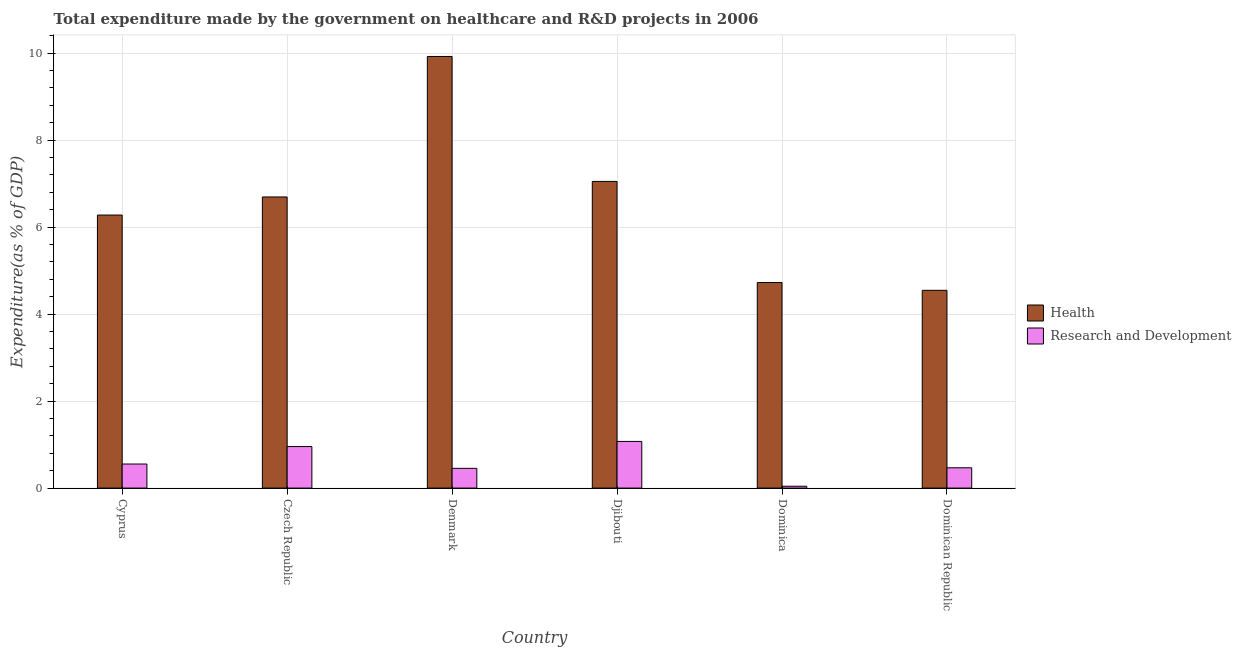Are the number of bars per tick equal to the number of legend labels?
Ensure brevity in your answer.  Yes. Are the number of bars on each tick of the X-axis equal?
Keep it short and to the point. Yes. How many bars are there on the 3rd tick from the left?
Provide a short and direct response. 2. What is the expenditure in r&d in Denmark?
Make the answer very short. 0.45. Across all countries, what is the maximum expenditure in r&d?
Your answer should be very brief. 1.07. Across all countries, what is the minimum expenditure in r&d?
Provide a succinct answer. 0.04. In which country was the expenditure in r&d maximum?
Provide a short and direct response. Djibouti. In which country was the expenditure in healthcare minimum?
Provide a short and direct response. Dominican Republic. What is the total expenditure in healthcare in the graph?
Your answer should be very brief. 39.22. What is the difference between the expenditure in r&d in Cyprus and that in Czech Republic?
Provide a succinct answer. -0.4. What is the difference between the expenditure in r&d in Djibouti and the expenditure in healthcare in Cyprus?
Keep it short and to the point. -5.21. What is the average expenditure in r&d per country?
Your answer should be very brief. 0.59. What is the difference between the expenditure in healthcare and expenditure in r&d in Dominica?
Offer a terse response. 4.68. What is the ratio of the expenditure in healthcare in Cyprus to that in Denmark?
Your answer should be compact. 0.63. Is the expenditure in healthcare in Czech Republic less than that in Dominican Republic?
Give a very brief answer. No. Is the difference between the expenditure in r&d in Cyprus and Czech Republic greater than the difference between the expenditure in healthcare in Cyprus and Czech Republic?
Offer a terse response. Yes. What is the difference between the highest and the second highest expenditure in healthcare?
Your response must be concise. 2.87. What is the difference between the highest and the lowest expenditure in r&d?
Ensure brevity in your answer.  1.03. Is the sum of the expenditure in r&d in Dominica and Dominican Republic greater than the maximum expenditure in healthcare across all countries?
Give a very brief answer. No. What does the 1st bar from the left in Dominican Republic represents?
Ensure brevity in your answer.  Health. What does the 1st bar from the right in Cyprus represents?
Keep it short and to the point. Research and Development. Are all the bars in the graph horizontal?
Offer a terse response. No. How many countries are there in the graph?
Your answer should be compact. 6. What is the difference between two consecutive major ticks on the Y-axis?
Make the answer very short. 2. Are the values on the major ticks of Y-axis written in scientific E-notation?
Ensure brevity in your answer.  No. Where does the legend appear in the graph?
Your answer should be very brief. Center right. How many legend labels are there?
Offer a very short reply. 2. What is the title of the graph?
Your response must be concise. Total expenditure made by the government on healthcare and R&D projects in 2006. What is the label or title of the Y-axis?
Make the answer very short. Expenditure(as % of GDP). What is the Expenditure(as % of GDP) in Health in Cyprus?
Your answer should be compact. 6.28. What is the Expenditure(as % of GDP) in Research and Development in Cyprus?
Offer a terse response. 0.55. What is the Expenditure(as % of GDP) in Health in Czech Republic?
Your answer should be compact. 6.69. What is the Expenditure(as % of GDP) of Research and Development in Czech Republic?
Offer a terse response. 0.95. What is the Expenditure(as % of GDP) of Health in Denmark?
Make the answer very short. 9.92. What is the Expenditure(as % of GDP) in Research and Development in Denmark?
Your answer should be very brief. 0.45. What is the Expenditure(as % of GDP) of Health in Djibouti?
Your answer should be very brief. 7.05. What is the Expenditure(as % of GDP) of Research and Development in Djibouti?
Your response must be concise. 1.07. What is the Expenditure(as % of GDP) of Health in Dominica?
Your answer should be compact. 4.73. What is the Expenditure(as % of GDP) in Research and Development in Dominica?
Keep it short and to the point. 0.04. What is the Expenditure(as % of GDP) of Health in Dominican Republic?
Your response must be concise. 4.55. What is the Expenditure(as % of GDP) in Research and Development in Dominican Republic?
Ensure brevity in your answer.  0.47. Across all countries, what is the maximum Expenditure(as % of GDP) of Health?
Provide a short and direct response. 9.92. Across all countries, what is the maximum Expenditure(as % of GDP) of Research and Development?
Give a very brief answer. 1.07. Across all countries, what is the minimum Expenditure(as % of GDP) in Health?
Offer a terse response. 4.55. Across all countries, what is the minimum Expenditure(as % of GDP) of Research and Development?
Your answer should be very brief. 0.04. What is the total Expenditure(as % of GDP) in Health in the graph?
Offer a very short reply. 39.22. What is the total Expenditure(as % of GDP) of Research and Development in the graph?
Give a very brief answer. 3.54. What is the difference between the Expenditure(as % of GDP) in Health in Cyprus and that in Czech Republic?
Make the answer very short. -0.42. What is the difference between the Expenditure(as % of GDP) of Research and Development in Cyprus and that in Czech Republic?
Ensure brevity in your answer.  -0.4. What is the difference between the Expenditure(as % of GDP) in Health in Cyprus and that in Denmark?
Keep it short and to the point. -3.65. What is the difference between the Expenditure(as % of GDP) of Research and Development in Cyprus and that in Denmark?
Provide a succinct answer. 0.1. What is the difference between the Expenditure(as % of GDP) of Health in Cyprus and that in Djibouti?
Your answer should be compact. -0.77. What is the difference between the Expenditure(as % of GDP) in Research and Development in Cyprus and that in Djibouti?
Your answer should be compact. -0.52. What is the difference between the Expenditure(as % of GDP) in Health in Cyprus and that in Dominica?
Provide a succinct answer. 1.55. What is the difference between the Expenditure(as % of GDP) of Research and Development in Cyprus and that in Dominica?
Your answer should be compact. 0.51. What is the difference between the Expenditure(as % of GDP) of Health in Cyprus and that in Dominican Republic?
Offer a terse response. 1.73. What is the difference between the Expenditure(as % of GDP) in Research and Development in Cyprus and that in Dominican Republic?
Keep it short and to the point. 0.09. What is the difference between the Expenditure(as % of GDP) in Health in Czech Republic and that in Denmark?
Make the answer very short. -3.23. What is the difference between the Expenditure(as % of GDP) of Research and Development in Czech Republic and that in Denmark?
Offer a very short reply. 0.5. What is the difference between the Expenditure(as % of GDP) in Health in Czech Republic and that in Djibouti?
Provide a short and direct response. -0.36. What is the difference between the Expenditure(as % of GDP) in Research and Development in Czech Republic and that in Djibouti?
Your answer should be very brief. -0.12. What is the difference between the Expenditure(as % of GDP) in Health in Czech Republic and that in Dominica?
Keep it short and to the point. 1.97. What is the difference between the Expenditure(as % of GDP) of Research and Development in Czech Republic and that in Dominica?
Provide a short and direct response. 0.91. What is the difference between the Expenditure(as % of GDP) in Health in Czech Republic and that in Dominican Republic?
Your response must be concise. 2.15. What is the difference between the Expenditure(as % of GDP) of Research and Development in Czech Republic and that in Dominican Republic?
Your answer should be compact. 0.49. What is the difference between the Expenditure(as % of GDP) of Health in Denmark and that in Djibouti?
Offer a very short reply. 2.87. What is the difference between the Expenditure(as % of GDP) of Research and Development in Denmark and that in Djibouti?
Offer a terse response. -0.62. What is the difference between the Expenditure(as % of GDP) of Health in Denmark and that in Dominica?
Ensure brevity in your answer.  5.2. What is the difference between the Expenditure(as % of GDP) of Research and Development in Denmark and that in Dominica?
Offer a very short reply. 0.41. What is the difference between the Expenditure(as % of GDP) in Health in Denmark and that in Dominican Republic?
Make the answer very short. 5.38. What is the difference between the Expenditure(as % of GDP) in Research and Development in Denmark and that in Dominican Republic?
Give a very brief answer. -0.01. What is the difference between the Expenditure(as % of GDP) of Health in Djibouti and that in Dominica?
Provide a succinct answer. 2.32. What is the difference between the Expenditure(as % of GDP) of Research and Development in Djibouti and that in Dominica?
Provide a succinct answer. 1.03. What is the difference between the Expenditure(as % of GDP) in Health in Djibouti and that in Dominican Republic?
Keep it short and to the point. 2.5. What is the difference between the Expenditure(as % of GDP) of Research and Development in Djibouti and that in Dominican Republic?
Provide a succinct answer. 0.61. What is the difference between the Expenditure(as % of GDP) of Health in Dominica and that in Dominican Republic?
Provide a short and direct response. 0.18. What is the difference between the Expenditure(as % of GDP) in Research and Development in Dominica and that in Dominican Republic?
Provide a short and direct response. -0.42. What is the difference between the Expenditure(as % of GDP) in Health in Cyprus and the Expenditure(as % of GDP) in Research and Development in Czech Republic?
Offer a terse response. 5.32. What is the difference between the Expenditure(as % of GDP) of Health in Cyprus and the Expenditure(as % of GDP) of Research and Development in Denmark?
Your answer should be very brief. 5.82. What is the difference between the Expenditure(as % of GDP) in Health in Cyprus and the Expenditure(as % of GDP) in Research and Development in Djibouti?
Ensure brevity in your answer.  5.21. What is the difference between the Expenditure(as % of GDP) of Health in Cyprus and the Expenditure(as % of GDP) of Research and Development in Dominica?
Offer a terse response. 6.24. What is the difference between the Expenditure(as % of GDP) of Health in Cyprus and the Expenditure(as % of GDP) of Research and Development in Dominican Republic?
Ensure brevity in your answer.  5.81. What is the difference between the Expenditure(as % of GDP) of Health in Czech Republic and the Expenditure(as % of GDP) of Research and Development in Denmark?
Give a very brief answer. 6.24. What is the difference between the Expenditure(as % of GDP) of Health in Czech Republic and the Expenditure(as % of GDP) of Research and Development in Djibouti?
Your answer should be very brief. 5.62. What is the difference between the Expenditure(as % of GDP) of Health in Czech Republic and the Expenditure(as % of GDP) of Research and Development in Dominica?
Your response must be concise. 6.65. What is the difference between the Expenditure(as % of GDP) of Health in Czech Republic and the Expenditure(as % of GDP) of Research and Development in Dominican Republic?
Offer a terse response. 6.23. What is the difference between the Expenditure(as % of GDP) in Health in Denmark and the Expenditure(as % of GDP) in Research and Development in Djibouti?
Provide a short and direct response. 8.85. What is the difference between the Expenditure(as % of GDP) in Health in Denmark and the Expenditure(as % of GDP) in Research and Development in Dominica?
Give a very brief answer. 9.88. What is the difference between the Expenditure(as % of GDP) in Health in Denmark and the Expenditure(as % of GDP) in Research and Development in Dominican Republic?
Provide a succinct answer. 9.46. What is the difference between the Expenditure(as % of GDP) in Health in Djibouti and the Expenditure(as % of GDP) in Research and Development in Dominica?
Ensure brevity in your answer.  7.01. What is the difference between the Expenditure(as % of GDP) in Health in Djibouti and the Expenditure(as % of GDP) in Research and Development in Dominican Republic?
Keep it short and to the point. 6.58. What is the difference between the Expenditure(as % of GDP) in Health in Dominica and the Expenditure(as % of GDP) in Research and Development in Dominican Republic?
Your answer should be compact. 4.26. What is the average Expenditure(as % of GDP) of Health per country?
Your answer should be compact. 6.54. What is the average Expenditure(as % of GDP) of Research and Development per country?
Make the answer very short. 0.59. What is the difference between the Expenditure(as % of GDP) of Health and Expenditure(as % of GDP) of Research and Development in Cyprus?
Ensure brevity in your answer.  5.72. What is the difference between the Expenditure(as % of GDP) of Health and Expenditure(as % of GDP) of Research and Development in Czech Republic?
Your answer should be very brief. 5.74. What is the difference between the Expenditure(as % of GDP) of Health and Expenditure(as % of GDP) of Research and Development in Denmark?
Keep it short and to the point. 9.47. What is the difference between the Expenditure(as % of GDP) of Health and Expenditure(as % of GDP) of Research and Development in Djibouti?
Make the answer very short. 5.98. What is the difference between the Expenditure(as % of GDP) in Health and Expenditure(as % of GDP) in Research and Development in Dominica?
Your answer should be compact. 4.68. What is the difference between the Expenditure(as % of GDP) in Health and Expenditure(as % of GDP) in Research and Development in Dominican Republic?
Ensure brevity in your answer.  4.08. What is the ratio of the Expenditure(as % of GDP) of Health in Cyprus to that in Czech Republic?
Ensure brevity in your answer.  0.94. What is the ratio of the Expenditure(as % of GDP) of Research and Development in Cyprus to that in Czech Republic?
Provide a short and direct response. 0.58. What is the ratio of the Expenditure(as % of GDP) in Health in Cyprus to that in Denmark?
Keep it short and to the point. 0.63. What is the ratio of the Expenditure(as % of GDP) of Research and Development in Cyprus to that in Denmark?
Give a very brief answer. 1.22. What is the ratio of the Expenditure(as % of GDP) in Health in Cyprus to that in Djibouti?
Your answer should be compact. 0.89. What is the ratio of the Expenditure(as % of GDP) of Research and Development in Cyprus to that in Djibouti?
Your answer should be compact. 0.52. What is the ratio of the Expenditure(as % of GDP) of Health in Cyprus to that in Dominica?
Your answer should be very brief. 1.33. What is the ratio of the Expenditure(as % of GDP) of Research and Development in Cyprus to that in Dominica?
Offer a terse response. 13.03. What is the ratio of the Expenditure(as % of GDP) in Health in Cyprus to that in Dominican Republic?
Your answer should be very brief. 1.38. What is the ratio of the Expenditure(as % of GDP) in Research and Development in Cyprus to that in Dominican Republic?
Provide a succinct answer. 1.19. What is the ratio of the Expenditure(as % of GDP) in Health in Czech Republic to that in Denmark?
Provide a succinct answer. 0.67. What is the ratio of the Expenditure(as % of GDP) of Research and Development in Czech Republic to that in Denmark?
Your answer should be compact. 2.1. What is the ratio of the Expenditure(as % of GDP) of Health in Czech Republic to that in Djibouti?
Provide a succinct answer. 0.95. What is the ratio of the Expenditure(as % of GDP) of Research and Development in Czech Republic to that in Djibouti?
Make the answer very short. 0.89. What is the ratio of the Expenditure(as % of GDP) of Health in Czech Republic to that in Dominica?
Offer a terse response. 1.42. What is the ratio of the Expenditure(as % of GDP) in Research and Development in Czech Republic to that in Dominica?
Provide a short and direct response. 22.49. What is the ratio of the Expenditure(as % of GDP) of Health in Czech Republic to that in Dominican Republic?
Provide a short and direct response. 1.47. What is the ratio of the Expenditure(as % of GDP) in Research and Development in Czech Republic to that in Dominican Republic?
Provide a short and direct response. 2.04. What is the ratio of the Expenditure(as % of GDP) in Health in Denmark to that in Djibouti?
Provide a short and direct response. 1.41. What is the ratio of the Expenditure(as % of GDP) in Research and Development in Denmark to that in Djibouti?
Provide a succinct answer. 0.42. What is the ratio of the Expenditure(as % of GDP) in Health in Denmark to that in Dominica?
Your answer should be compact. 2.1. What is the ratio of the Expenditure(as % of GDP) in Research and Development in Denmark to that in Dominica?
Your answer should be very brief. 10.7. What is the ratio of the Expenditure(as % of GDP) in Health in Denmark to that in Dominican Republic?
Give a very brief answer. 2.18. What is the ratio of the Expenditure(as % of GDP) of Research and Development in Denmark to that in Dominican Republic?
Ensure brevity in your answer.  0.97. What is the ratio of the Expenditure(as % of GDP) in Health in Djibouti to that in Dominica?
Give a very brief answer. 1.49. What is the ratio of the Expenditure(as % of GDP) of Research and Development in Djibouti to that in Dominica?
Provide a short and direct response. 25.28. What is the ratio of the Expenditure(as % of GDP) in Health in Djibouti to that in Dominican Republic?
Offer a very short reply. 1.55. What is the ratio of the Expenditure(as % of GDP) of Research and Development in Djibouti to that in Dominican Republic?
Make the answer very short. 2.3. What is the ratio of the Expenditure(as % of GDP) of Health in Dominica to that in Dominican Republic?
Make the answer very short. 1.04. What is the ratio of the Expenditure(as % of GDP) in Research and Development in Dominica to that in Dominican Republic?
Keep it short and to the point. 0.09. What is the difference between the highest and the second highest Expenditure(as % of GDP) of Health?
Offer a terse response. 2.87. What is the difference between the highest and the second highest Expenditure(as % of GDP) in Research and Development?
Provide a short and direct response. 0.12. What is the difference between the highest and the lowest Expenditure(as % of GDP) of Health?
Ensure brevity in your answer.  5.38. What is the difference between the highest and the lowest Expenditure(as % of GDP) in Research and Development?
Your answer should be very brief. 1.03. 